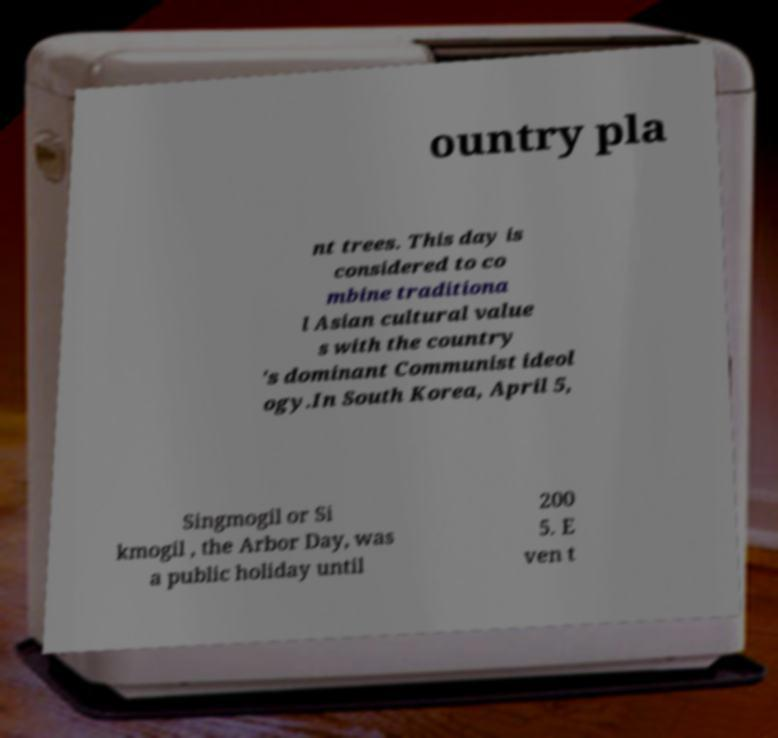What messages or text are displayed in this image? I need them in a readable, typed format. ountry pla nt trees. This day is considered to co mbine traditiona l Asian cultural value s with the country 's dominant Communist ideol ogy.In South Korea, April 5, Singmogil or Si kmogil , the Arbor Day, was a public holiday until 200 5. E ven t 